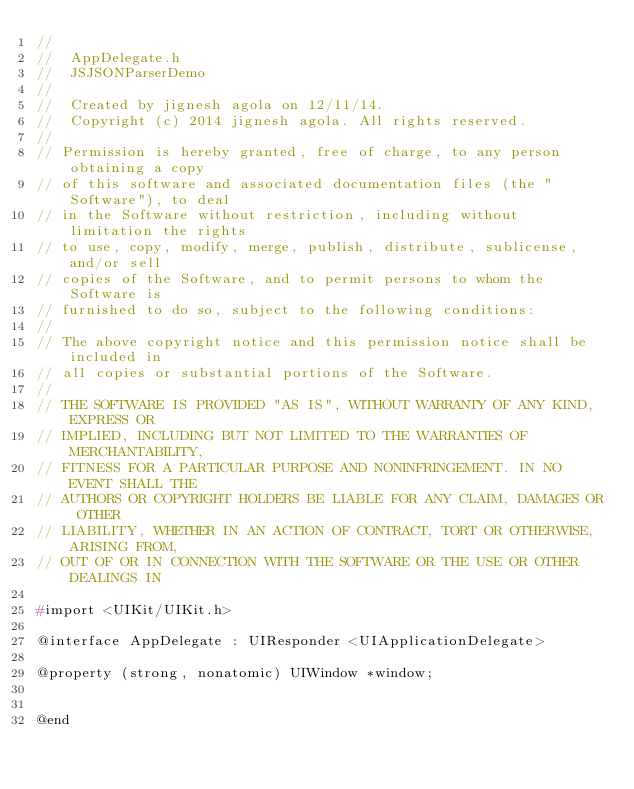<code> <loc_0><loc_0><loc_500><loc_500><_C_>//
//  AppDelegate.h
//  JSJSONParserDemo
//
//  Created by jignesh agola on 12/11/14.
//  Copyright (c) 2014 jignesh agola. All rights reserved.
//
// Permission is hereby granted, free of charge, to any person obtaining a copy
// of this software and associated documentation files (the "Software"), to deal
// in the Software without restriction, including without limitation the rights
// to use, copy, modify, merge, publish, distribute, sublicense, and/or sell
// copies of the Software, and to permit persons to whom the Software is
// furnished to do so, subject to the following conditions:
//
// The above copyright notice and this permission notice shall be included in
// all copies or substantial portions of the Software.
//
// THE SOFTWARE IS PROVIDED "AS IS", WITHOUT WARRANTY OF ANY KIND, EXPRESS OR
// IMPLIED, INCLUDING BUT NOT LIMITED TO THE WARRANTIES OF MERCHANTABILITY,
// FITNESS FOR A PARTICULAR PURPOSE AND NONINFRINGEMENT. IN NO EVENT SHALL THE
// AUTHORS OR COPYRIGHT HOLDERS BE LIABLE FOR ANY CLAIM, DAMAGES OR OTHER
// LIABILITY, WHETHER IN AN ACTION OF CONTRACT, TORT OR OTHERWISE, ARISING FROM,
// OUT OF OR IN CONNECTION WITH THE SOFTWARE OR THE USE OR OTHER DEALINGS IN

#import <UIKit/UIKit.h>

@interface AppDelegate : UIResponder <UIApplicationDelegate>

@property (strong, nonatomic) UIWindow *window;


@end

</code> 